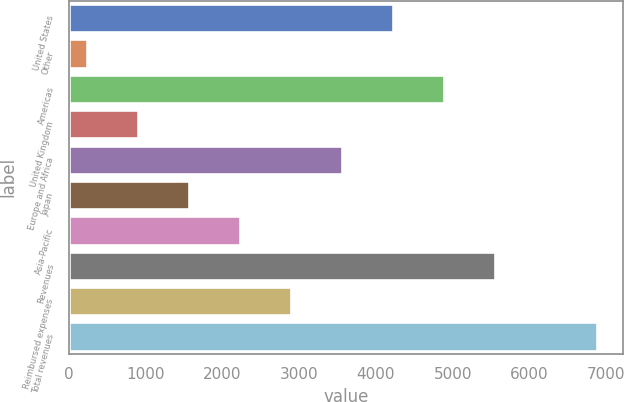Convert chart. <chart><loc_0><loc_0><loc_500><loc_500><bar_chart><fcel>United States<fcel>Other<fcel>Americas<fcel>United Kingdom<fcel>Europe and Africa<fcel>Japan<fcel>Asia-Pacific<fcel>Revenues<fcel>Reimbursed expenses<fcel>Total revenues<nl><fcel>4220<fcel>233<fcel>4884.5<fcel>897.5<fcel>3555.5<fcel>1562<fcel>2226.5<fcel>5549<fcel>2891<fcel>6878<nl></chart> 